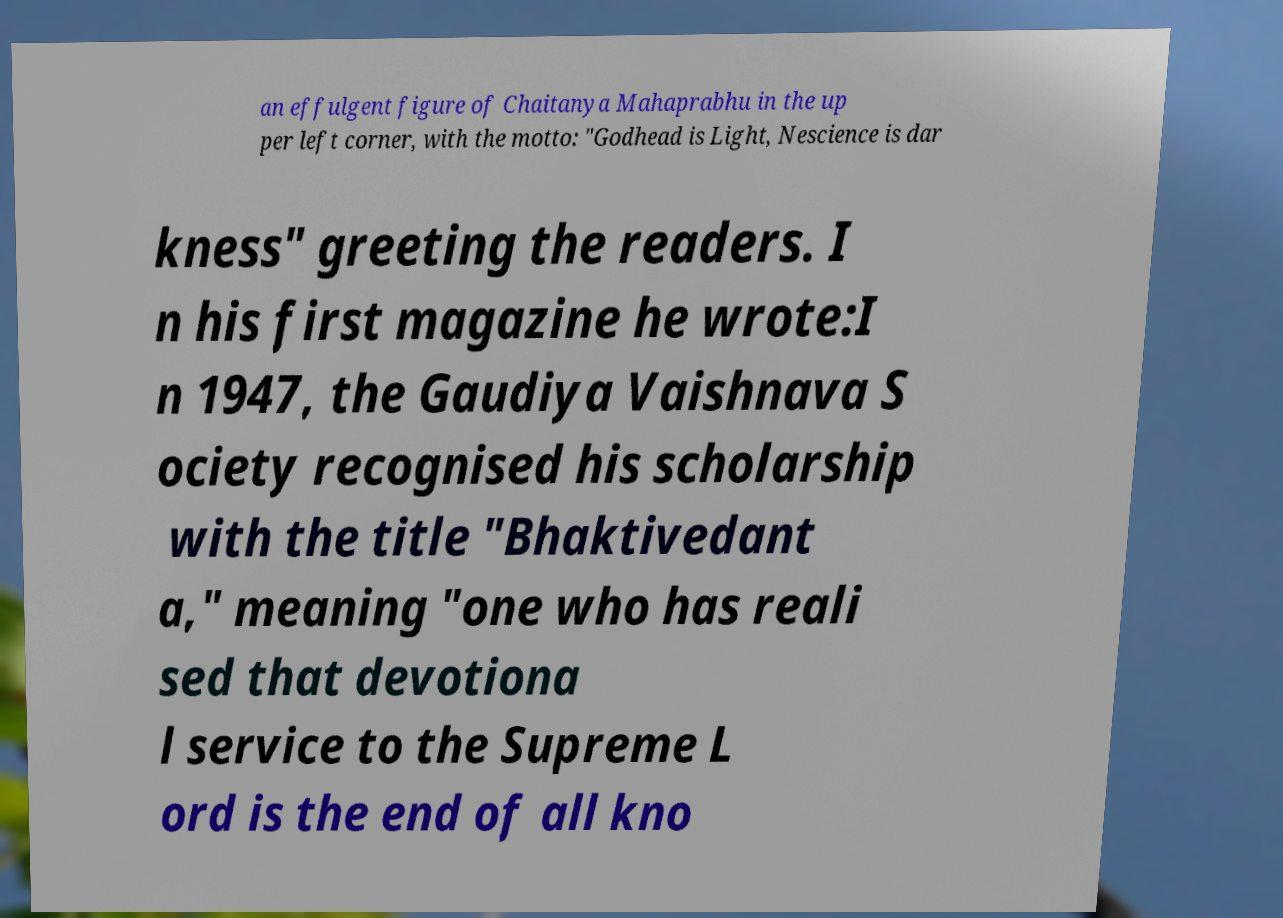Please identify and transcribe the text found in this image. an effulgent figure of Chaitanya Mahaprabhu in the up per left corner, with the motto: "Godhead is Light, Nescience is dar kness" greeting the readers. I n his first magazine he wrote:I n 1947, the Gaudiya Vaishnava S ociety recognised his scholarship with the title "Bhaktivedant a," meaning "one who has reali sed that devotiona l service to the Supreme L ord is the end of all kno 